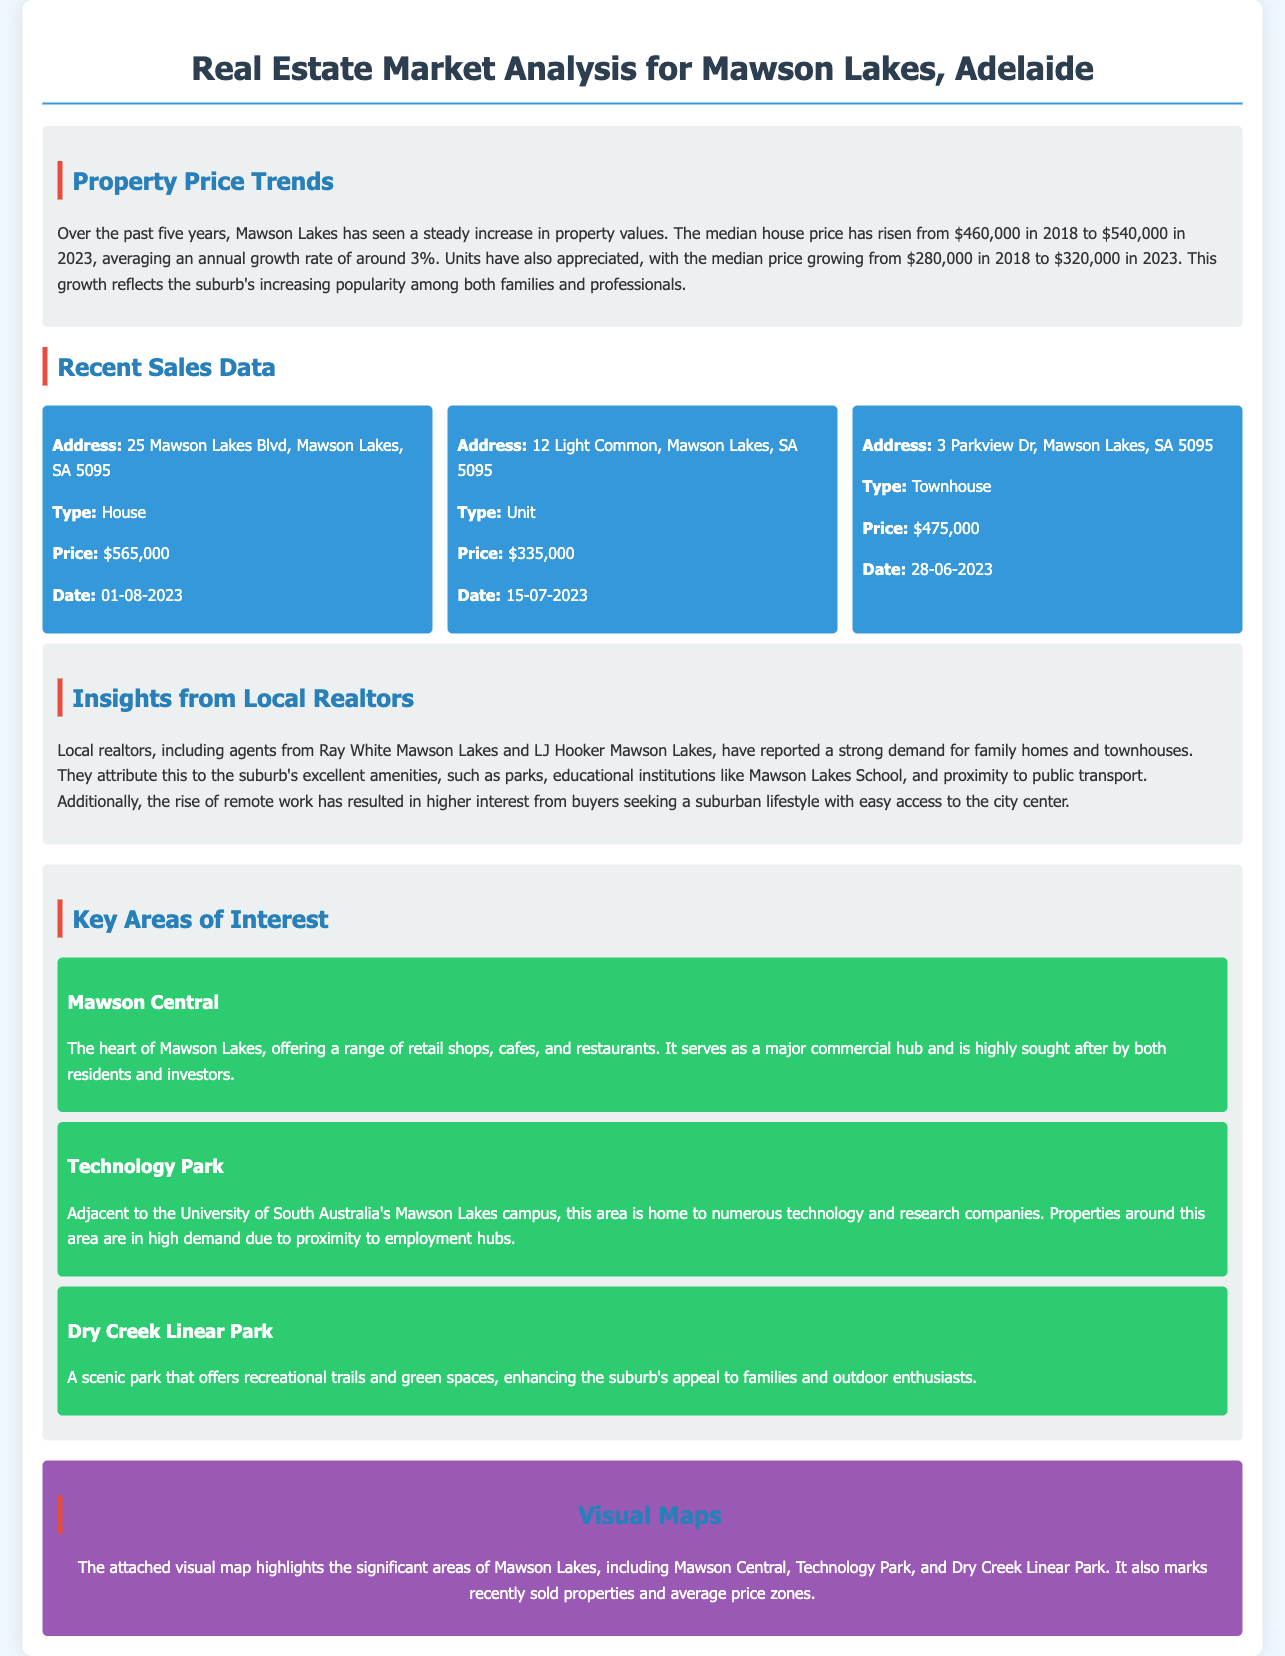what was the median house price in Mawson Lakes in 2023? The median house price in 2023 was stated as $540,000.
Answer: $540,000 what is the percentage increase in the median price of units over the five years? The increase in median price of units is from $280,000 in 2018 to $320,000 in 2023, which shows a difference of $40,000. The percentage increase is calculated as ($40,000/$280,000) * 100%.
Answer: 14.29% how many recent sales are displayed in the document? The document lists three recent sales with transaction details.
Answer: three what type of property was sold at 25 Mawson Lakes Blvd? The document categorizes the property type at 25 Mawson Lakes Blvd as a house.
Answer: House which area is described as the heart of Mawson Lakes? The document refers to Mawson Central as the heart of Mawson Lakes.
Answer: Mawson Central who reported strong demand for family homes? Local realtors, including agents from Ray White Mawson Lakes and LJ Hooker Mawson Lakes reported this demand.
Answer: Local realtors when was the property sold at 12 Light Common? The sale date for the property at 12 Light Common is mentioned as July 15, 2023.
Answer: 15-07-2023 what key amenity is mentioned near Technology Park? The document states that Technology Park is adjacent to the University of South Australia's Mawson Lakes campus.
Answer: University of South Australia what color is used for the background of the visual map section? The background color of the visual map section is described as a shade of purple.
Answer: Purple 